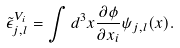<formula> <loc_0><loc_0><loc_500><loc_500>\tilde { \epsilon } ^ { V _ { i } } _ { j , l } = \int d ^ { 3 } x \frac { \partial \phi } { \partial x _ { i } } \psi _ { j , l } ( { x } ) .</formula> 